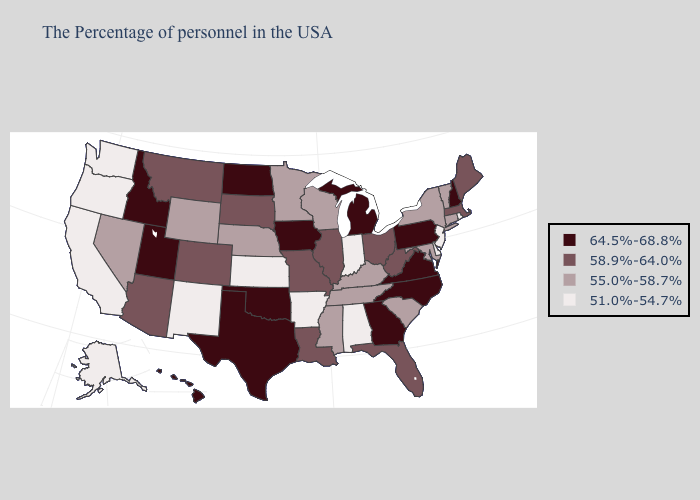What is the value of Wyoming?
Keep it brief. 55.0%-58.7%. What is the value of Florida?
Be succinct. 58.9%-64.0%. Which states have the lowest value in the South?
Concise answer only. Delaware, Alabama, Arkansas. Does Kentucky have the highest value in the USA?
Concise answer only. No. Does the first symbol in the legend represent the smallest category?
Keep it brief. No. Does Florida have a lower value than North Dakota?
Short answer required. Yes. What is the value of Georgia?
Short answer required. 64.5%-68.8%. Which states have the highest value in the USA?
Keep it brief. New Hampshire, Pennsylvania, Virginia, North Carolina, Georgia, Michigan, Iowa, Oklahoma, Texas, North Dakota, Utah, Idaho, Hawaii. What is the value of Maryland?
Short answer required. 55.0%-58.7%. What is the value of Michigan?
Short answer required. 64.5%-68.8%. Does the map have missing data?
Concise answer only. No. Does Tennessee have the lowest value in the USA?
Keep it brief. No. Does California have the highest value in the West?
Short answer required. No. Among the states that border Montana , which have the highest value?
Short answer required. North Dakota, Idaho. 